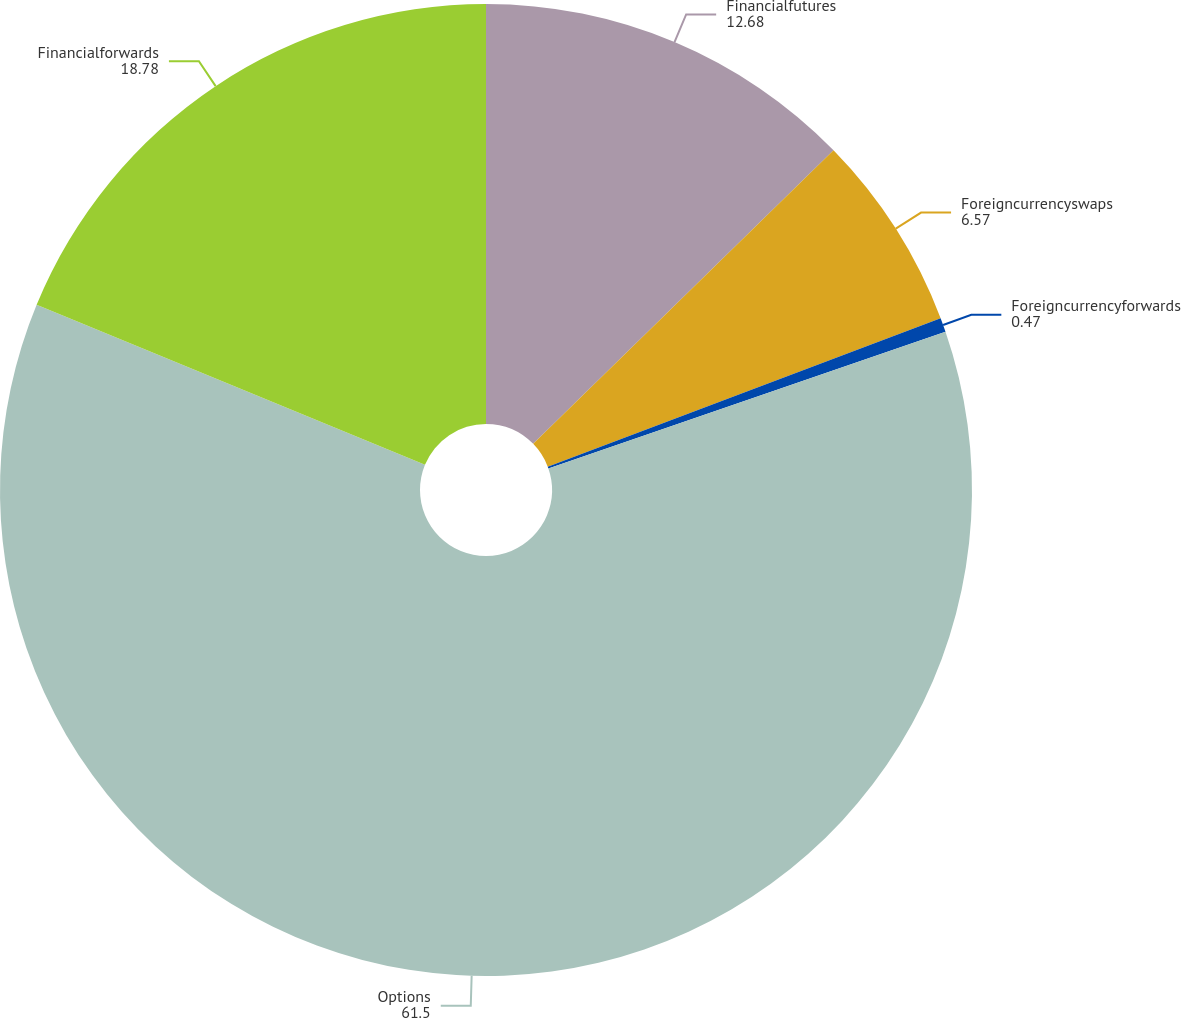Convert chart to OTSL. <chart><loc_0><loc_0><loc_500><loc_500><pie_chart><fcel>Financialfutures<fcel>Foreigncurrencyswaps<fcel>Foreigncurrencyforwards<fcel>Options<fcel>Financialforwards<nl><fcel>12.68%<fcel>6.57%<fcel>0.47%<fcel>61.5%<fcel>18.78%<nl></chart> 